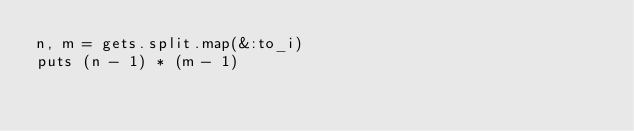<code> <loc_0><loc_0><loc_500><loc_500><_Ruby_>n, m = gets.split.map(&:to_i)
puts (n - 1) * (m - 1)
</code> 